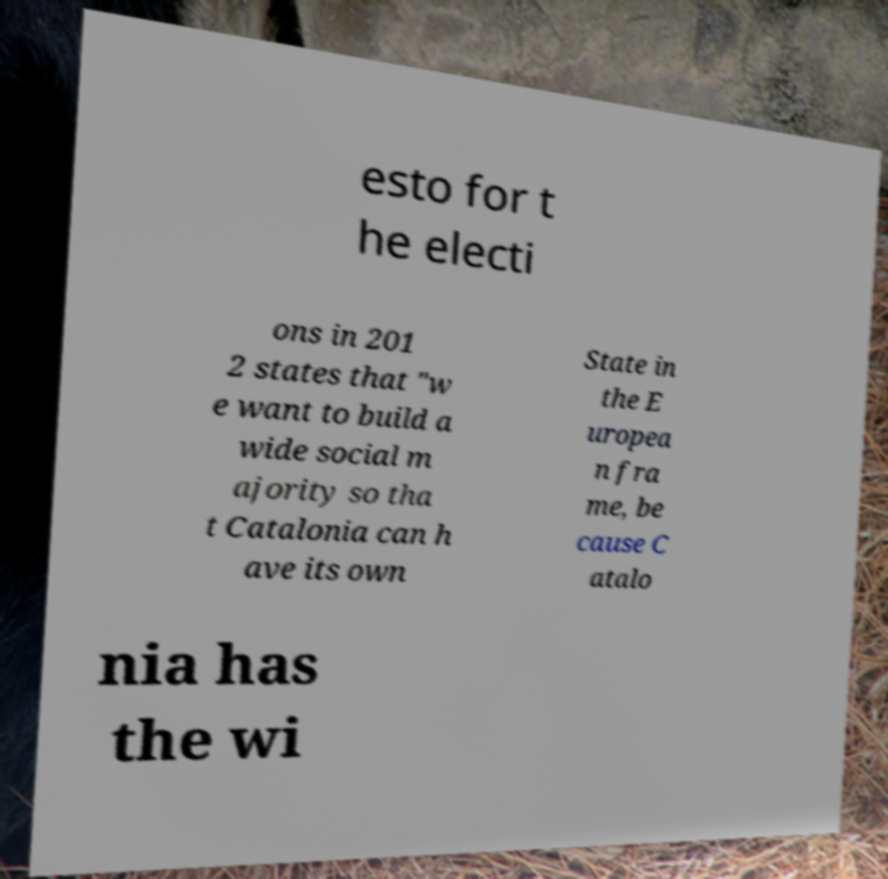Can you accurately transcribe the text from the provided image for me? esto for t he electi ons in 201 2 states that "w e want to build a wide social m ajority so tha t Catalonia can h ave its own State in the E uropea n fra me, be cause C atalo nia has the wi 